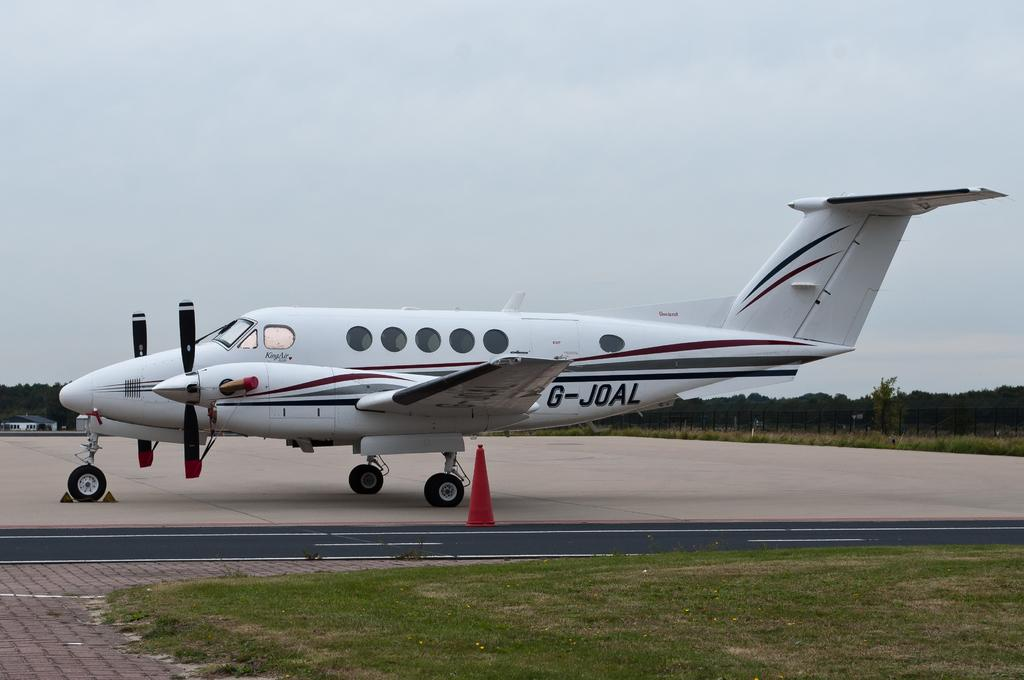<image>
Render a clear and concise summary of the photo. an airplane on the runway that says g-jdal 